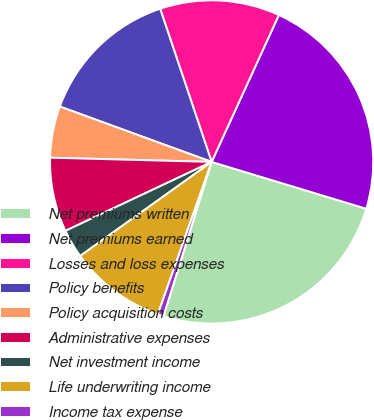Convert chart to OTSL. <chart><loc_0><loc_0><loc_500><loc_500><pie_chart><fcel>Net premiums written<fcel>Net premiums earned<fcel>Losses and loss expenses<fcel>Policy benefits<fcel>Policy acquisition costs<fcel>Administrative expenses<fcel>Net investment income<fcel>Life underwriting income<fcel>Income tax expense<nl><fcel>25.13%<fcel>22.85%<fcel>11.99%<fcel>14.27%<fcel>5.15%<fcel>7.43%<fcel>2.87%<fcel>9.71%<fcel>0.59%<nl></chart> 